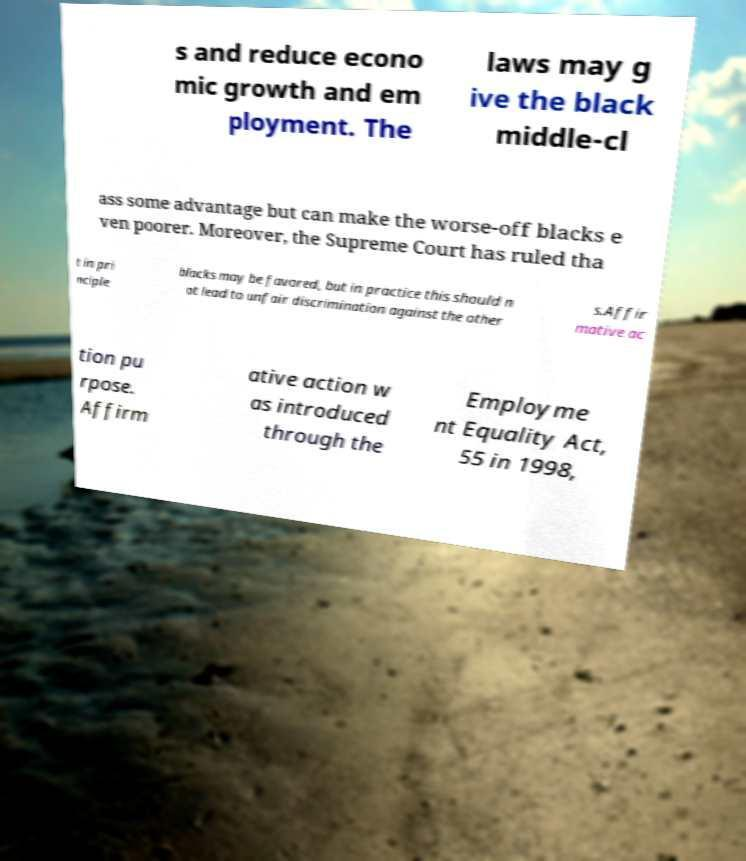Can you accurately transcribe the text from the provided image for me? s and reduce econo mic growth and em ployment. The laws may g ive the black middle-cl ass some advantage but can make the worse-off blacks e ven poorer. Moreover, the Supreme Court has ruled tha t in pri nciple blacks may be favored, but in practice this should n ot lead to unfair discrimination against the other s.Affir mative ac tion pu rpose. Affirm ative action w as introduced through the Employme nt Equality Act, 55 in 1998, 